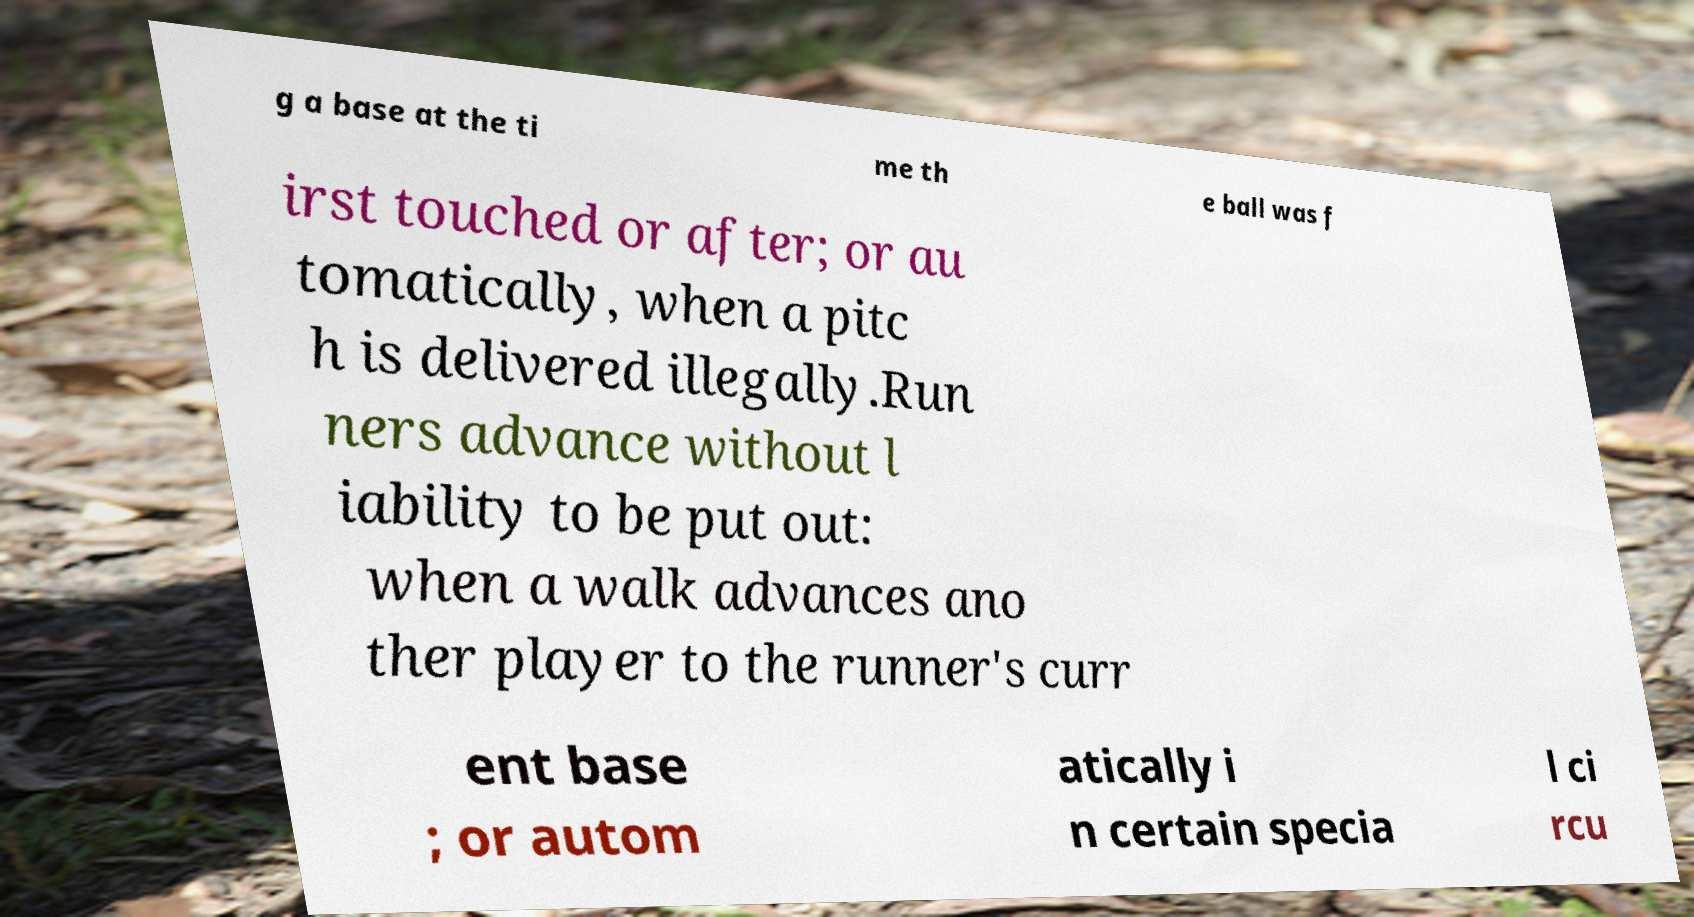What messages or text are displayed in this image? I need them in a readable, typed format. g a base at the ti me th e ball was f irst touched or after; or au tomatically, when a pitc h is delivered illegally.Run ners advance without l iability to be put out: when a walk advances ano ther player to the runner's curr ent base ; or autom atically i n certain specia l ci rcu 